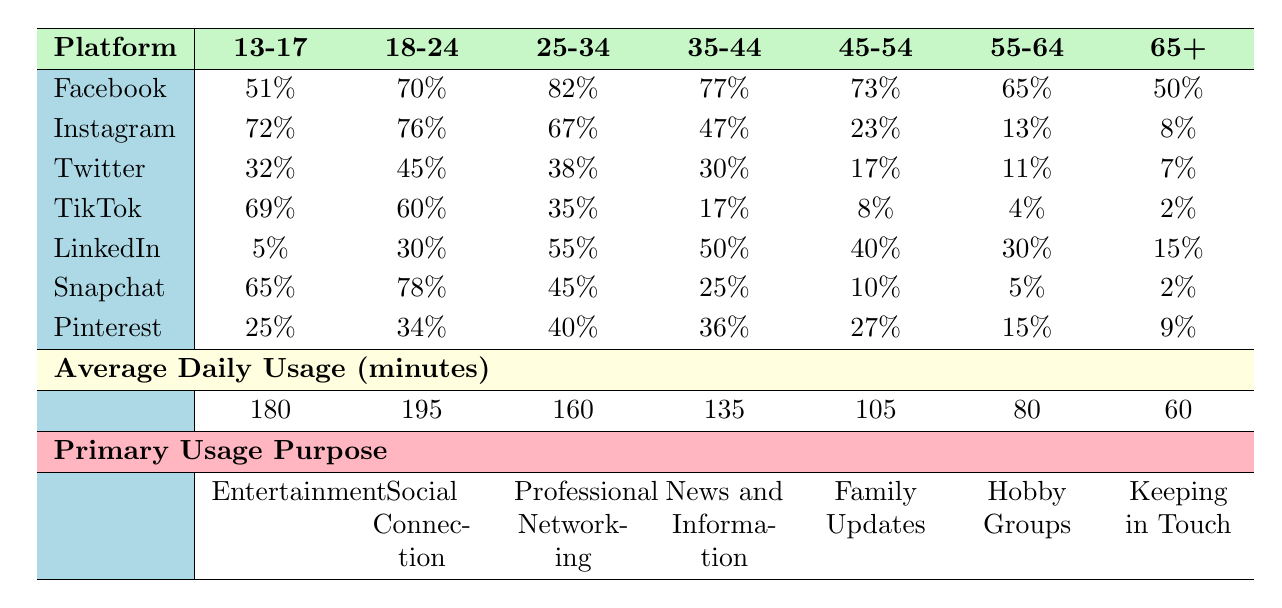What percentage of the 13-17 age group uses Instagram? According to the table, under the Instagram column for the age group 13-17, the percentage is 72%.
Answer: 72% Which age group has the highest percentage of Facebook usage? The age group 25-34 has the highest percentage of Facebook usage at 82%, as indicated in the Facebook column.
Answer: 25-34 What is the average daily usage in minutes for the 45-54 age group? The table shows that the average daily usage for the age group 45-54 is 105 minutes, which is directly provided in the corresponding row.
Answer: 105 Are there more users in the 18-24 age group who use Snapchat compared to the 35-44 age group? For the Snapchat column, the 18-24 age group shows a usage of 78%, while the 35-44 age group shows 25%, indicating that 18-24 age group users are higher in number.
Answer: Yes What is the difference in average daily usage minutes between the 13-17 and 55-64 age groups? The average minutes for 13-17 is 180 and for 55-64 is 80. The difference is 180 - 80 = 100 minutes.
Answer: 100 Which age group has the lowest percentage of TikTok usage and what is that percentage? The age group 65+ shows the lowest percentage of TikTok usage at 2%, as shown in the TikTok column.
Answer: 2% Is the primary usage purpose for the 35-44 age group focused on entertainment? The primary usage purpose for the 35-44 age group is "News and Information," as indicated in the primary usage purpose section of the table.
Answer: No Combine the percentages for Instagram and Snapchat for the 25-34 age group. What is the total? For the age group 25-34, Instagram usage is 67% and Snapchat usage is 45%. Adding these gives 67 + 45 = 112%.
Answer: 112% What percentage of the 65+ age group uses Facebook? Looking at the Facebook column for the 65+ age group, the percentage is 50%.
Answer: 50% 